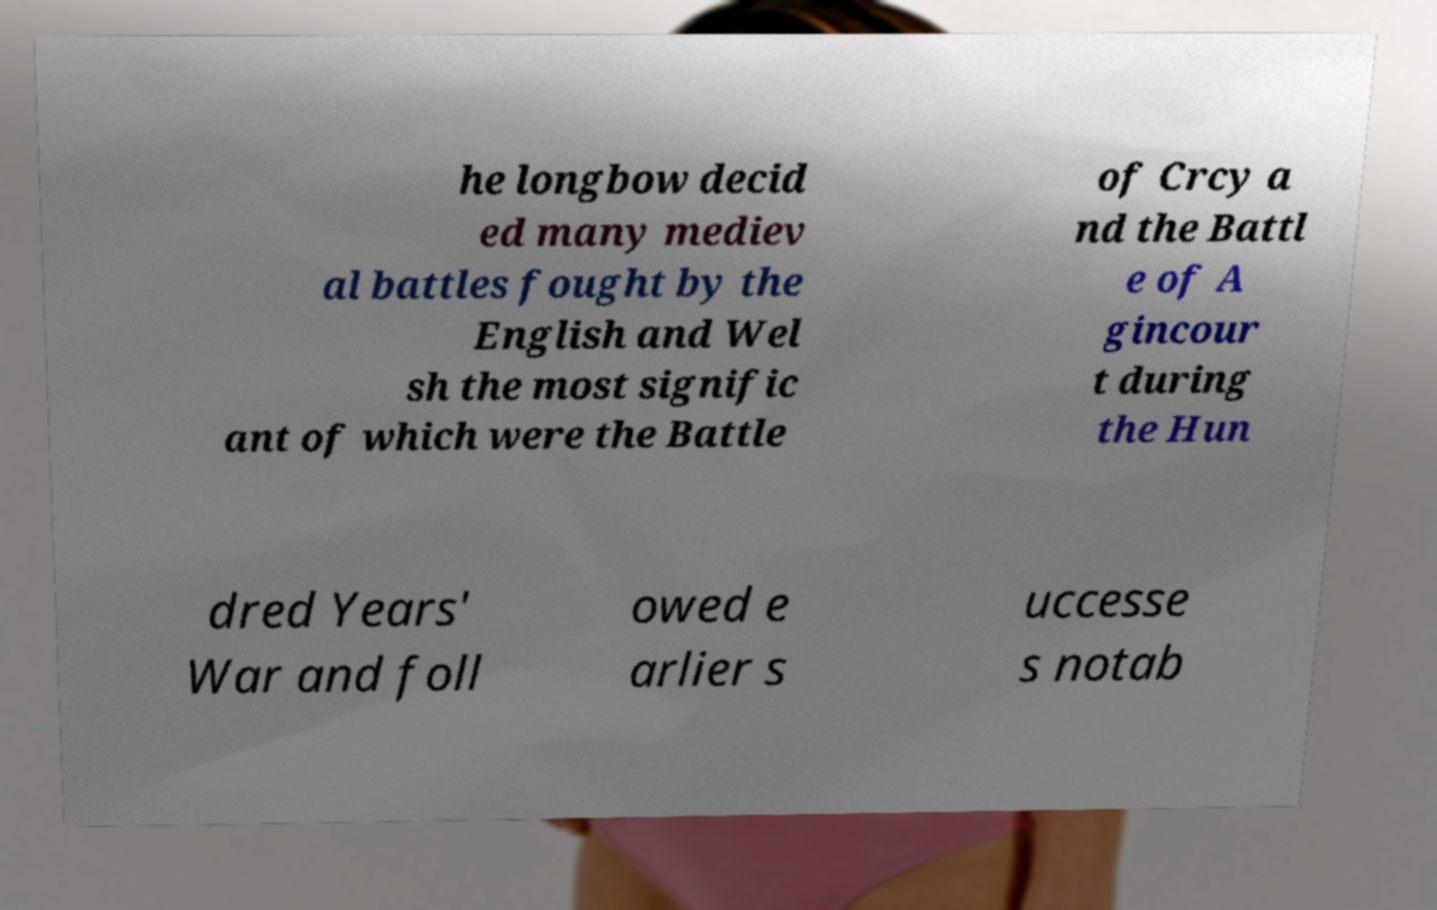What messages or text are displayed in this image? I need them in a readable, typed format. he longbow decid ed many mediev al battles fought by the English and Wel sh the most signific ant of which were the Battle of Crcy a nd the Battl e of A gincour t during the Hun dred Years' War and foll owed e arlier s uccesse s notab 